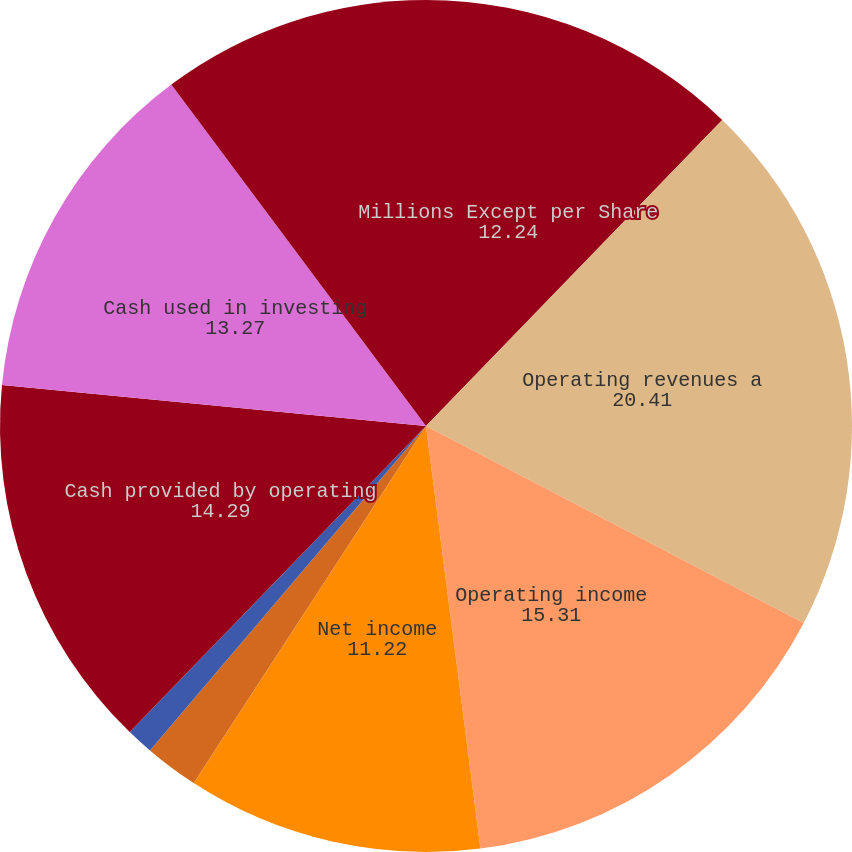<chart> <loc_0><loc_0><loc_500><loc_500><pie_chart><fcel>Millions Except per Share<fcel>Operating revenues a<fcel>Operating income<fcel>Net income<fcel>Earnings per share - basic b<fcel>Earnings per share - diluted b<fcel>Dividends declared per share b<fcel>Cash provided by operating<fcel>Cash used in investing<fcel>Cash used in financing<nl><fcel>12.24%<fcel>20.41%<fcel>15.31%<fcel>11.22%<fcel>2.04%<fcel>1.02%<fcel>0.0%<fcel>14.29%<fcel>13.27%<fcel>10.2%<nl></chart> 